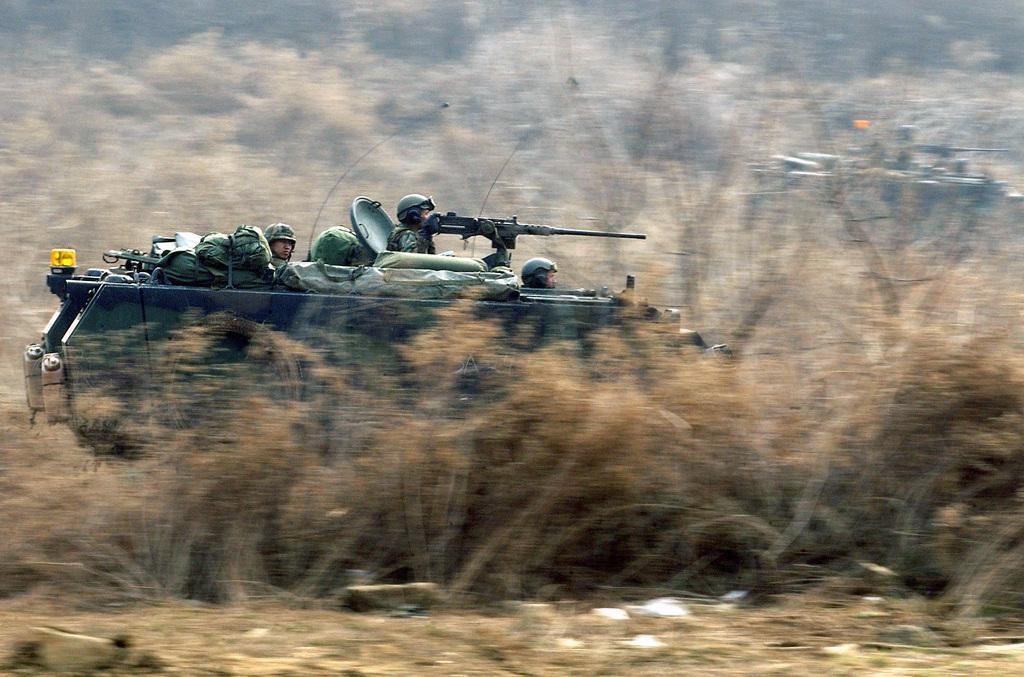How would you summarize this image in a sentence or two? In the foreground of the picture there are plants, soil, soldiers and an army tank. In the background there are plants and an army tank. 